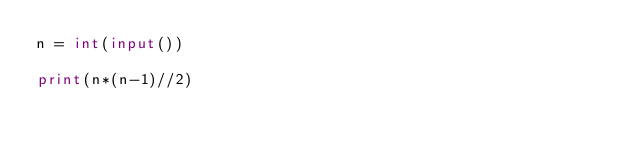Convert code to text. <code><loc_0><loc_0><loc_500><loc_500><_Python_>n = int(input())

print(n*(n-1)//2)</code> 